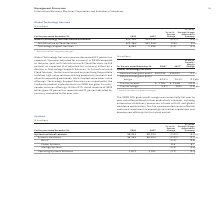According to International Business Machines's financial document, What was the focus area for business in Infrastructure & Cloud Services  In Infrastructure & Cloud Services, the business focused on prioritizing the portfolio to deliver high-value solutions to bring productivity to clients and allow for expanding workloads, while it exited some lower-value offerings.. The document states: "ffset by a decline in Technology Support Services. In Infrastructure & Cloud Services, the business focused on prioritizing the portfolio to deliver h..." Also, What impacted the Technology Support Services in 2018? Technology Support Services was impacted by the hardware product cycle dynamics in 2018. The document states: "oads, while it exited some lower-value offerings. Technology Support Services was impacted by the hardware product cycle dynamics in 2018 but grew its..." Also, How much did the cloud revenue grew within GTS? Within GTS, cloud revenue of $8.0 billion grew 22 percent as reported and 21 percent adjusted for currency compared to the prior year.. The document states: "018 but grew its multi- vendor services offerings. Within GTS, cloud revenue of $8.0 billion grew 22 percent as reported and 21 percent adjusted for c..." Also, can you calculate: What is the increase/ (decrease) in Global Technology Services external revenue from 2017 to 2018 Based on the calculation: 29,146-29,213 , the result is -67 (in millions). This is based on the information: "Global Technology Services external revenue $29,146 * $29,213 * (0.2)% (0.8)% l Technology Services external revenue $29,146 * $29,213 * (0.2)% (0.8)%..." The key data points involved are: 29,146, 29,213. Also, can you calculate: What is the average of Global Technology Services external revenue for the year 2018 and 2017 To answer this question, I need to perform calculations using the financial data. The calculation is: (29,146+29,213) / 2, which equals 29179.5 (in millions). This is based on the information: "Global Technology Services external revenue $29,146 * $29,213 * (0.2)% (0.8)% l Technology Services external revenue $29,146 * $29,213 * (0.2)% (0.8)%..." The key data points involved are: 29,146, 29,213. Also, can you calculate: What is the increase/ (decrease) in Technology Support Services from 2017 to 2018 Based on the calculation: 6,961-7,196, the result is -235 (in millions). This is based on the information: "Technology Support Services 6,961 7,196 (3.3) (3.5) Technology Support Services 6,961 7,196 (3.3) (3.5)..." The key data points involved are: 6,961, 7,196. 